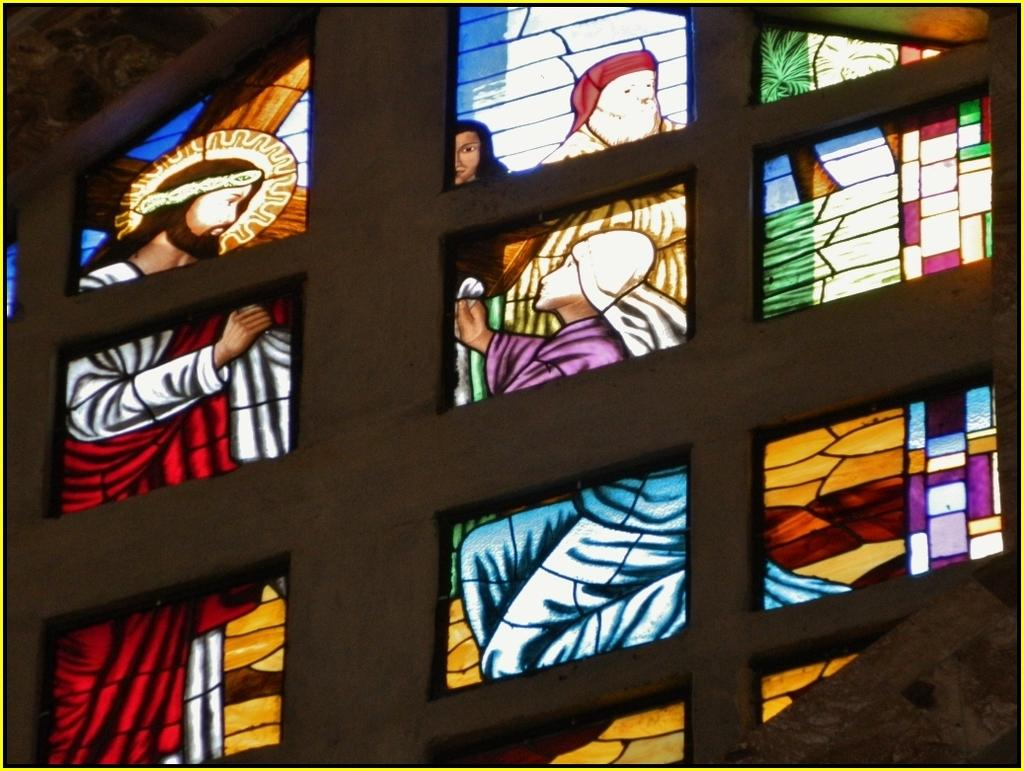What type of building is depicted in the image? The image shows an inside part of a church. What feature can be seen in the church? There is a glass wall in the image. What is depicted on the glass wall? The glass wall has paintings of Jesus and some people. How are the paintings displayed on the glass wall? There are frames on the glass wall. What type of coast can be seen through the glass wall in the image? There is no coast visible in the image, as it shows an inside part of a church with a glass wall featuring paintings. 